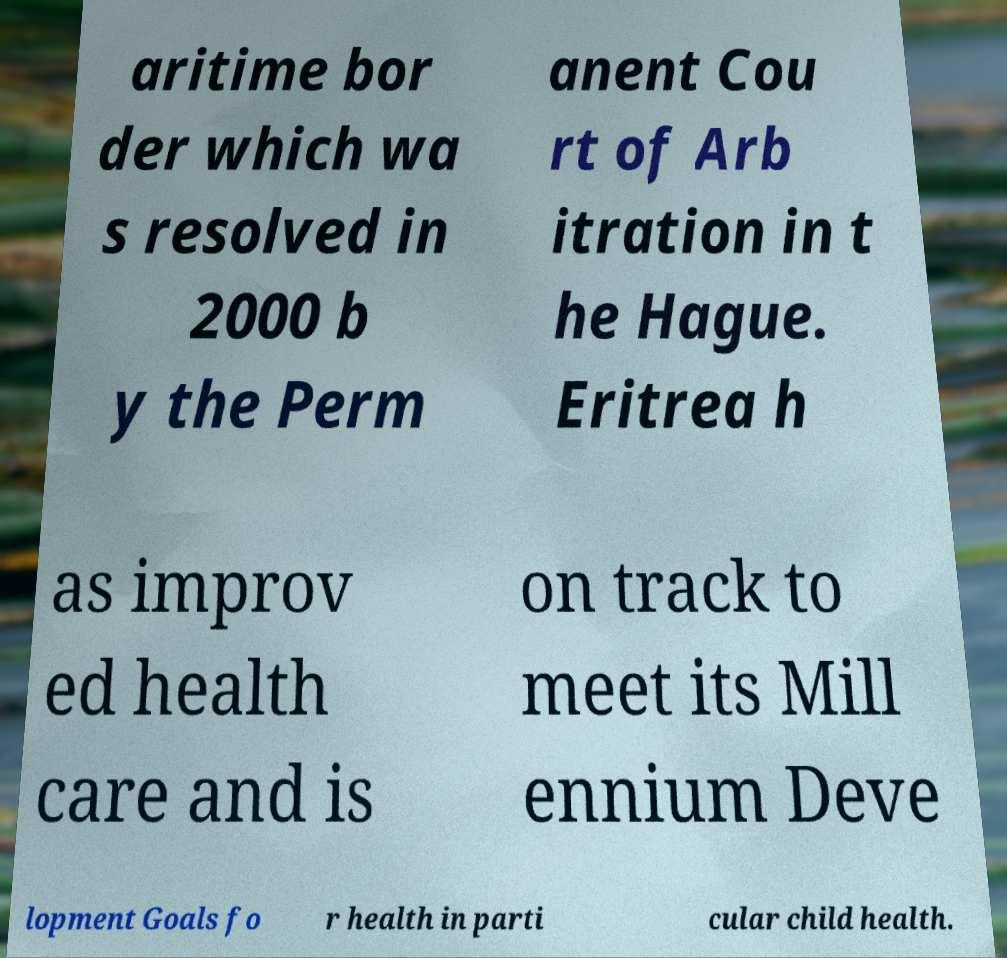Can you accurately transcribe the text from the provided image for me? aritime bor der which wa s resolved in 2000 b y the Perm anent Cou rt of Arb itration in t he Hague. Eritrea h as improv ed health care and is on track to meet its Mill ennium Deve lopment Goals fo r health in parti cular child health. 